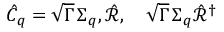Convert formula to latex. <formula><loc_0><loc_0><loc_500><loc_500>\hat { C } _ { q } = \sqrt { \Gamma } \, { \Sigma } _ { q } , \hat { \mathcal { R } } , \quad \sqrt { \Gamma } \, \Sigma _ { q } \hat { \mathcal { R } } ^ { \dag }</formula> 